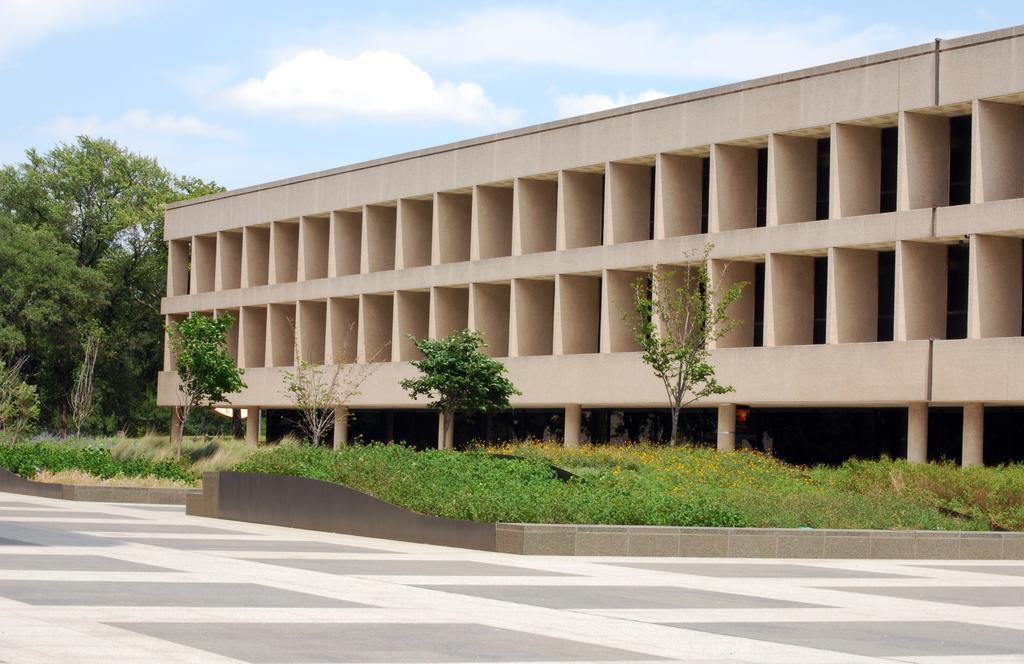Please provide a concise description of this image. In the middle of the image there are some plants and trees. Behind the trees there is a building. At the top of the image there are some clouds and sky. 